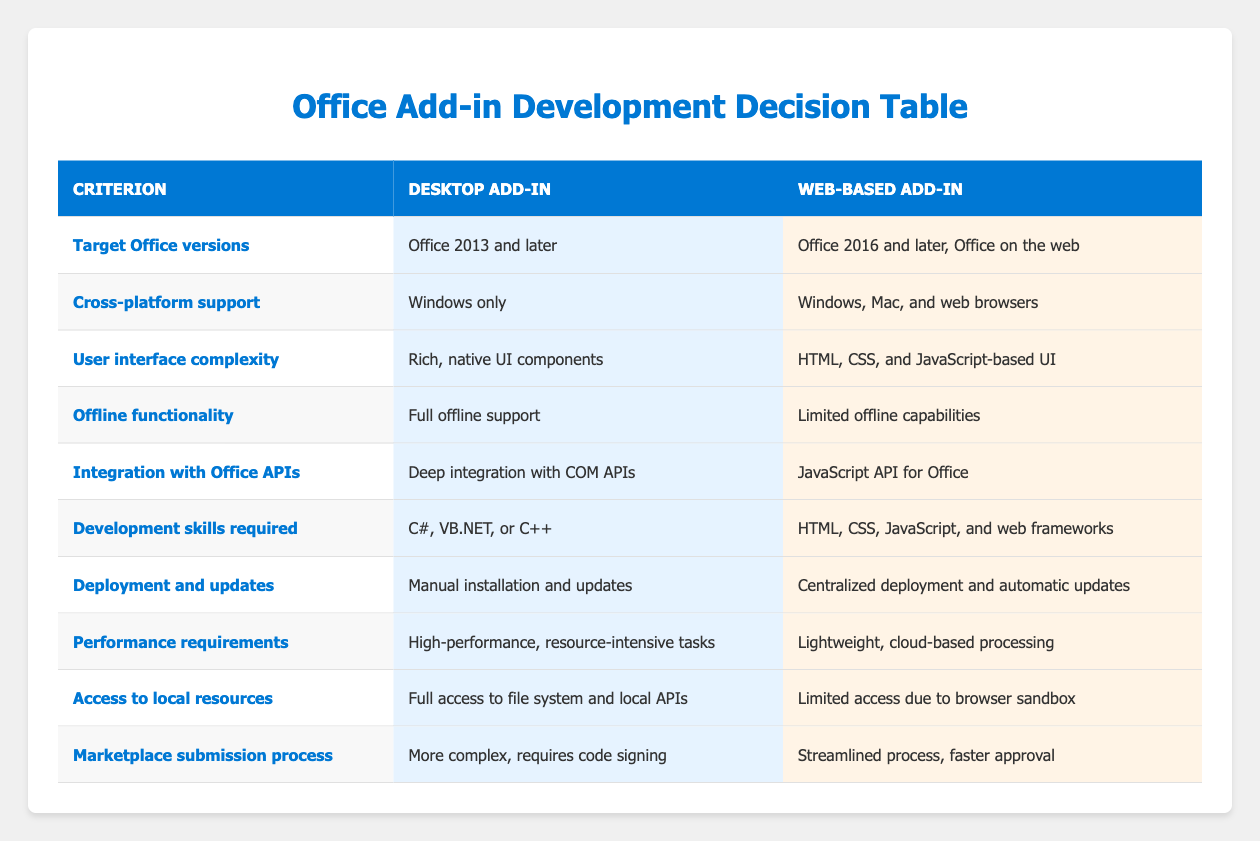What Office versions are supported by the Desktop Add-in? The table indicates that the Desktop Add-in supports "Office 2013 and later." This is found in the row labeled "Target Office versions" under the Desktop Add-in column.
Answer: Office 2013 and later Does the Web-based Add-in support cross-platform deployment? According to the table, the Web-based Add-in supports "Windows, Mac, and web browsers." This is in the row for "Cross-platform support."
Answer: Yes What is the main development skill required for a Web-based Add-in? From the table, the Web-based Add-in requires skills in "HTML, CSS, JavaScript, and web frameworks," as stated in the row for "Development skills required."
Answer: HTML, CSS, JavaScript, and web frameworks How does the offline functionality of Desktop Add-ins compare to Web-based Add-ins? The comparison shows that Desktop Add-ins offer "Full offline support," while Web-based Add-ins have "Limited offline capabilities." This is looked up in the row for "Offline functionality."
Answer: Desktop Add-ins have full support, Web-based have limited capabilities Which type of Add-in requires code signing during the Marketplace submission process? The table notes "more complex, requires code signing" for Desktop Add-ins under the "Marketplace submission process" criterion, indicating that Desktop Add-ins have this requirement while Web-based do not.
Answer: Desktop Add-in What are the performance requirements for a Web-based Add-in in comparison to a Desktop Add-in? The table indicates that Desktop Add-ins are suited for "high-performance, resource-intensive tasks," whereas Web-based Add-ins are geared towards "lightweight, cloud-based processing." Comparing both shows that Web-based is less demanding.
Answer: Web-based Add-ins require lightweight processing Is there any offline functionality provided by Web-based Add-ins? The table mentions that Web-based Add-ins have "Limited offline capabilities," therefore confirming that some level of offline functionality is offered, although not as extensive as that provided by Desktop Add-ins.
Answer: Yes What is the difference in access to local resources between Desktop and Web-based Add-ins? The Desktop Add-in has "Full access to file system and local APIs" while the Web-based Add-in has "Limited access due to browser sandbox." Thus, the Desktop Add-in has wider access compared to the Web-based version.
Answer: Desktop Add-in has full access, Web-based has limited access If a developer prefers native UI components, which add-in development should they choose? The table states that Desktop Add-ins feature "Rich, native UI components," whereas Web-based Add-ins are limited to "HTML, CSS, and JavaScript-based UI." This suggests Desktop Add-ins would be a better fit for developers preferring native components.
Answer: Desktop Add-in 